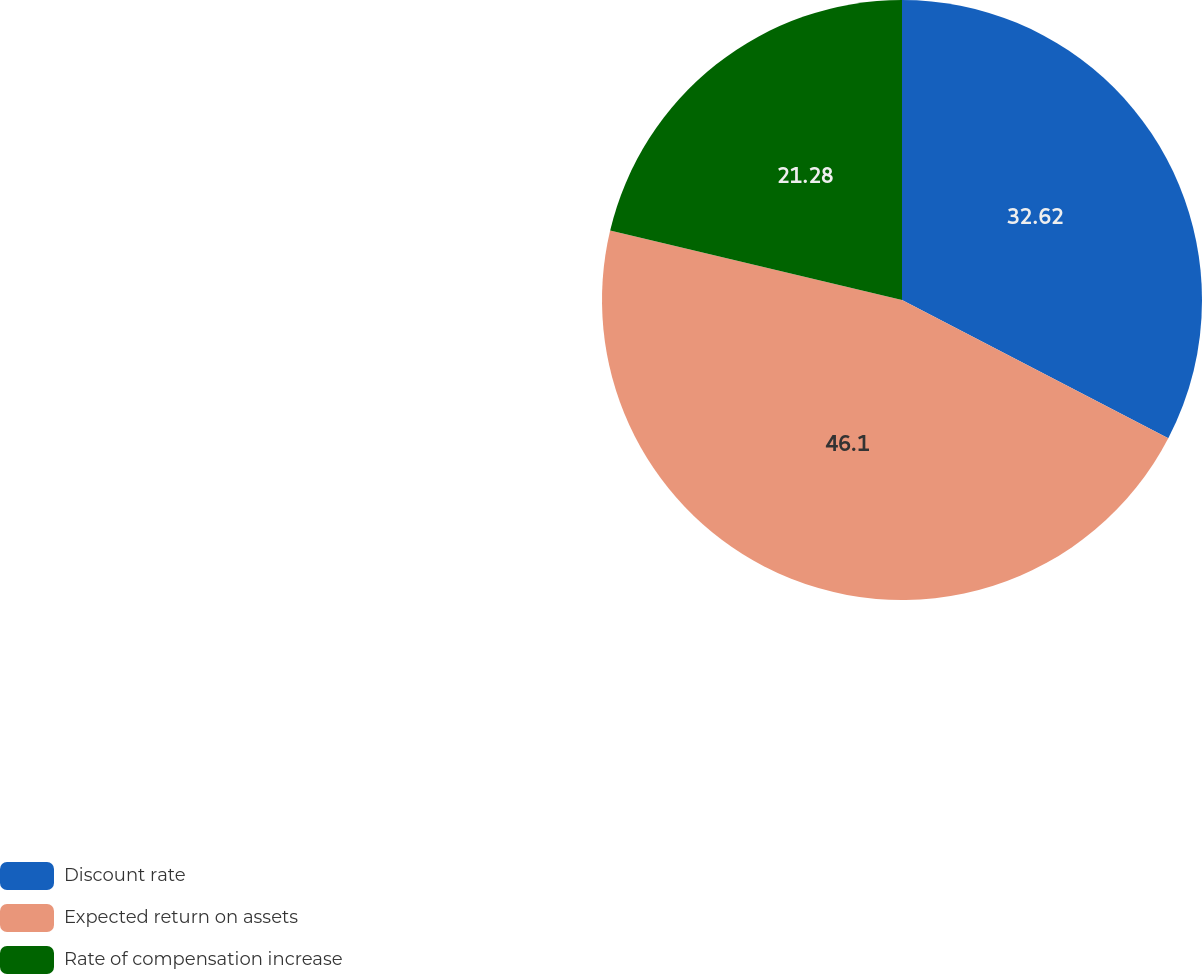Convert chart. <chart><loc_0><loc_0><loc_500><loc_500><pie_chart><fcel>Discount rate<fcel>Expected return on assets<fcel>Rate of compensation increase<nl><fcel>32.62%<fcel>46.1%<fcel>21.28%<nl></chart> 